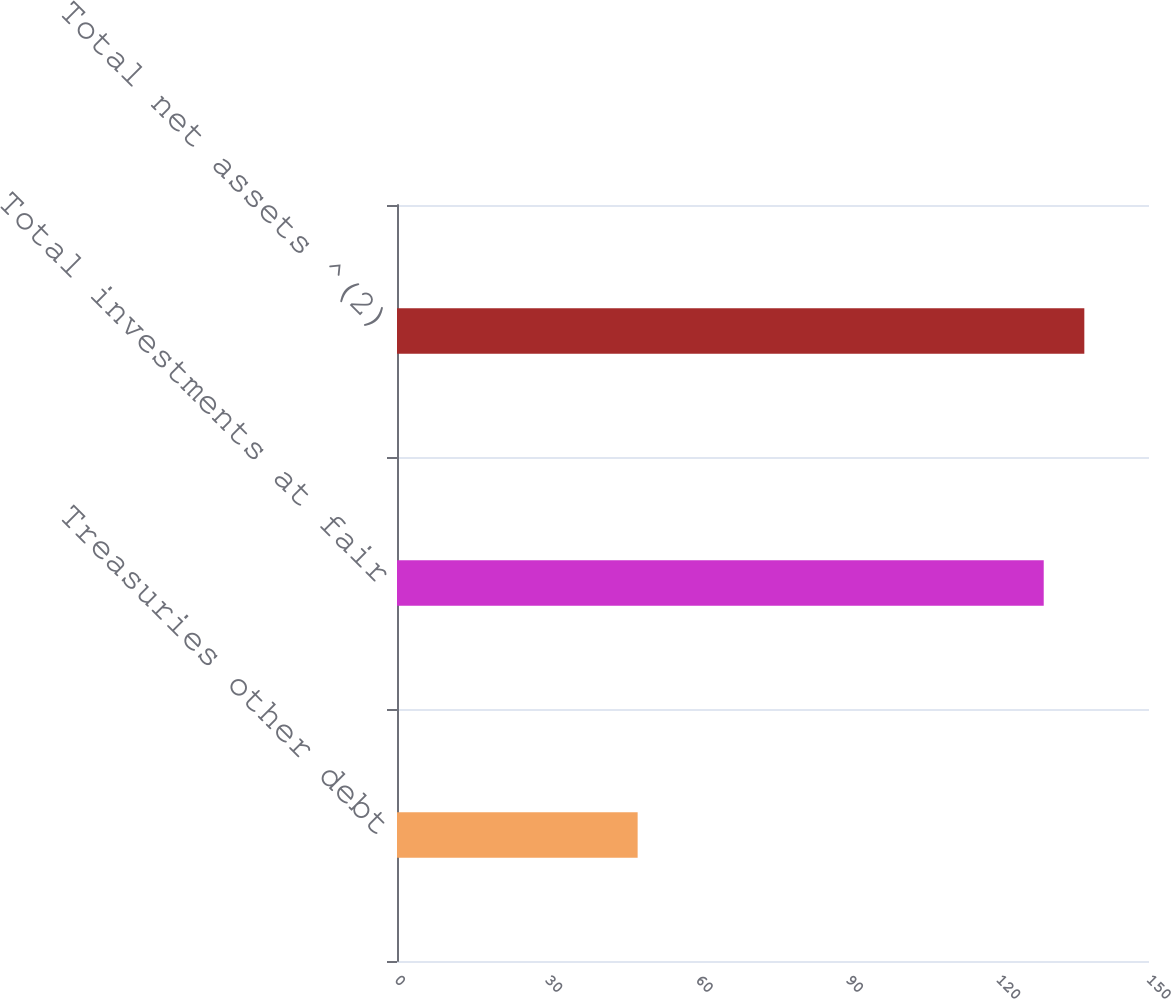<chart> <loc_0><loc_0><loc_500><loc_500><bar_chart><fcel>Treasuries other debt<fcel>Total investments at fair<fcel>Total net assets ^(2)<nl><fcel>48<fcel>129<fcel>137.1<nl></chart> 